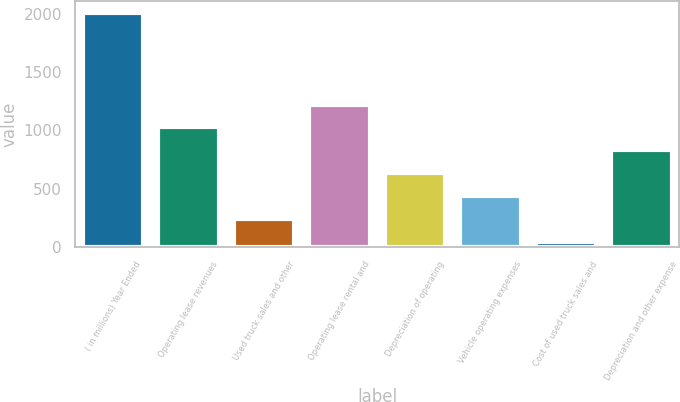Convert chart. <chart><loc_0><loc_0><loc_500><loc_500><bar_chart><fcel>( in millions) Year Ended<fcel>Operating lease revenues<fcel>Used truck sales and other<fcel>Operating lease rental and<fcel>Depreciation of operating<fcel>Vehicle operating expenses<fcel>Cost of used truck sales and<fcel>Depreciation and other expense<nl><fcel>2013<fcel>1025.6<fcel>235.68<fcel>1223.08<fcel>630.64<fcel>433.16<fcel>38.2<fcel>828.12<nl></chart> 